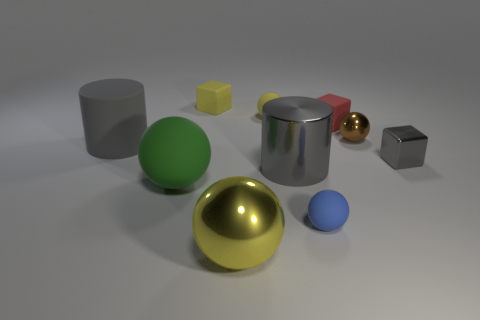Subtract all brown metal spheres. How many spheres are left? 4 Subtract all yellow cylinders. How many yellow balls are left? 2 Subtract 3 spheres. How many spheres are left? 2 Subtract all blue balls. How many balls are left? 4 Subtract 0 gray balls. How many objects are left? 10 Subtract all blocks. How many objects are left? 7 Subtract all blue blocks. Subtract all brown spheres. How many blocks are left? 3 Subtract all yellow shiny spheres. Subtract all large rubber cylinders. How many objects are left? 8 Add 4 gray matte cylinders. How many gray matte cylinders are left? 5 Add 3 metal things. How many metal things exist? 7 